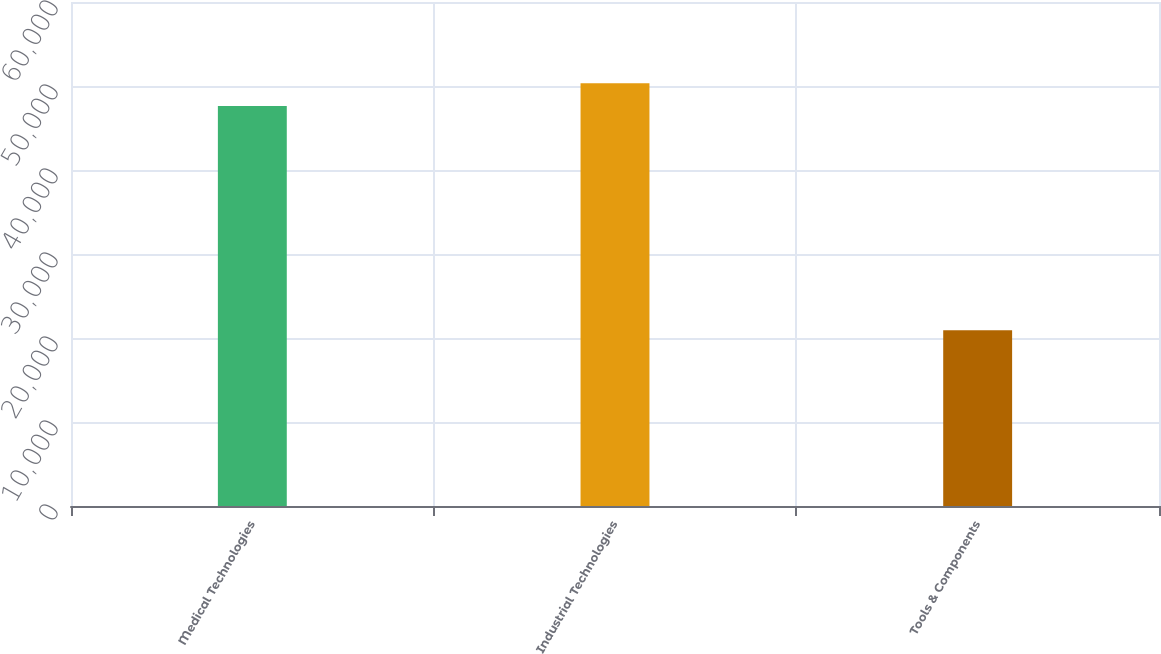Convert chart. <chart><loc_0><loc_0><loc_500><loc_500><bar_chart><fcel>Medical Technologies<fcel>Industrial Technologies<fcel>Tools & Components<nl><fcel>47618<fcel>50329.6<fcel>20908<nl></chart> 